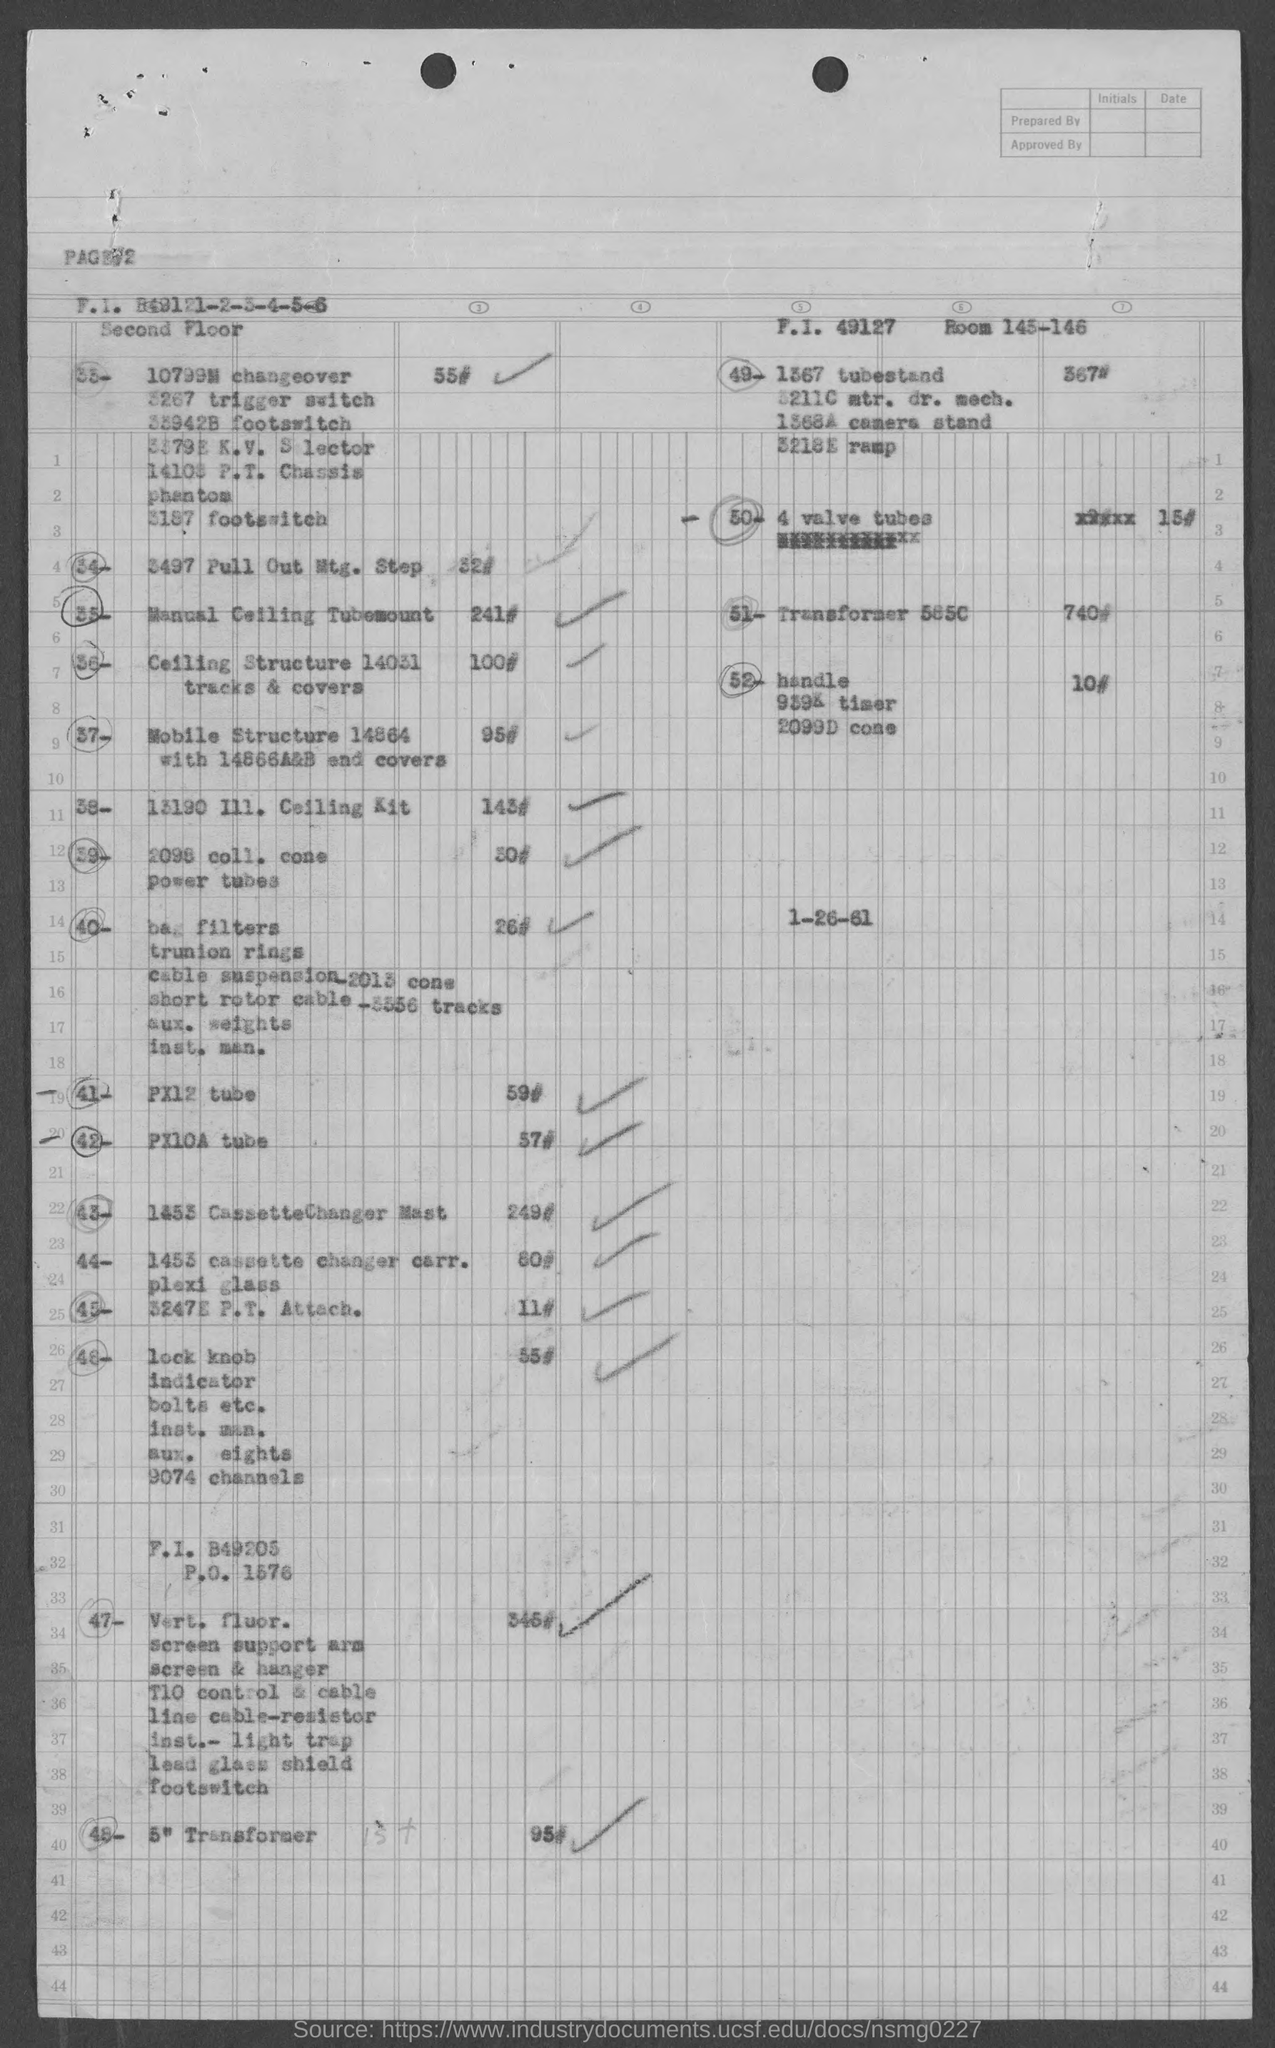What are the room numbers given in the top right corner?
Offer a very short reply. 145-146. 